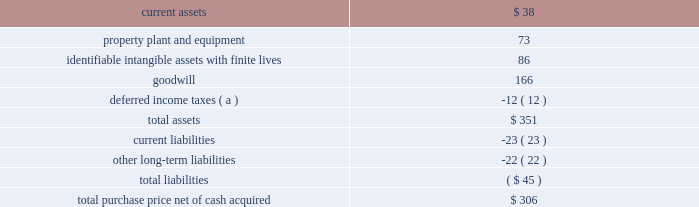58 2018 ppg annual report and 10-k the crown group on october 2 , 2017 , ppg acquired the crown group ( 201ccrown 201d ) , a u.s.-based coatings application services business , which is reported as part of ppg's industrial coatings reportable segment .
Crown is one of the leading component and product finishers in north america .
Crown applies coatings to customers 2019 manufactured parts and assembled products at 11 u.s .
Sites .
Most of crown 2019s facilities , which also provide assembly , warehousing and sequencing services , are located at customer facilities or positioned near customer manufacturing sites .
The company serves manufacturers in the automotive , agriculture , construction , heavy truck and alternative energy industries .
The pro-forma impact on ppg's sales and results of operations , including the pro forma effect of events that are directly attributable to the acquisition , was not significant .
The results of this business since the date of acquisition have been reported within the industrial coatings business within the industrial coatings reportable segment .
Taiwan chlorine industries taiwan chlorine industries ( 201ctci 201d ) was established in 1986 as a joint venture between ppg and china petrochemical development corporation ( 201ccpdc 201d ) to produce chlorine-based products in taiwan , at which time ppg owned 60 percent of the venture .
In conjunction with the 2013 separation of its commodity chemicals business , ppg conveyed to axiall corporation ( "axiall" ) its 60% ( 60 % ) ownership interest in tci .
Under ppg 2019s agreement with cpdc , if certain post-closing conditions were not met following the three year anniversary of the separation , cpdc had the option to sell its 40% ( 40 % ) ownership interest in tci to axiall for $ 100 million .
In turn , axiall had a right to designate ppg as its designee to purchase the 40% ( 40 % ) ownership interest of cpdc .
In april 2016 , axiall announced that cpdc had decided to sell its ownership interest in tci to axiall .
In june 2016 , axiall formally designated ppg to purchase the 40% ( 40 % ) ownership interest in tci .
In august 2016 , westlake chemical corporation acquired axiall , which became a wholly-owned subsidiary of westlake .
In april 2017 , ppg finalized its purchase of cpdc 2019s 40% ( 40 % ) ownership interest in tci .
The difference between the acquisition date fair value and the purchase price of ppg 2019s 40% ( 40 % ) ownership interest in tci has been recorded as a loss in discontinued operations during the year-ended december 31 , 2017 .
Ppg 2019s ownership in tci is accounted for as an equity method investment and the related equity earnings are reported within other income in the consolidated statement of income and in legacy in note 20 , 201creportable business segment information . 201d metokote corporation in july 2016 , ppg completed the acquisition of metokote corporation ( "metokote" ) , a u.s.-based coatings application services business .
Metokote applies coatings to customers' manufactured parts and assembled products .
It operates on- site coatings services within several customer manufacturing locations , as well as at regional service centers , located throughout the u.s. , canada , mexico , the united kingdom , germany , hungary and the czech republic .
Customers ship parts to metokote ae service centers where they are treated to enhance paint adhesion and painted with electrocoat , powder or liquid coatings technologies .
Coated parts are then shipped to the customer 2019s next stage of assembly .
Metokote coats an average of more than 1.5 million parts per day .
The table summarizes the estimated fair value of assets acquired and liabilities assumed as reflected in the final purchase price allocation for metokote .
( $ in millions ) .
( a ) the net deferred income tax liability is included in assets due to the company's tax jurisdictional netting .
The pro-forma impact on ppg's sales and results of operations , including the pro forma effect of events that are directly attributable to the acquisition , was not significant .
While calculating this impact , no cost savings or operating synergies that may result from the acquisition were included .
The results of this business since the date of acquisition have been reported within the industrial coatings business within the industrial coatings reportable segment .
Notes to the consolidated financial statements .
For metokote , what percentage of purchase price was intangible assets? 
Rationale: goodwill - intangibles
Computations: ((86 + 166) / 306)
Answer: 0.82353. 